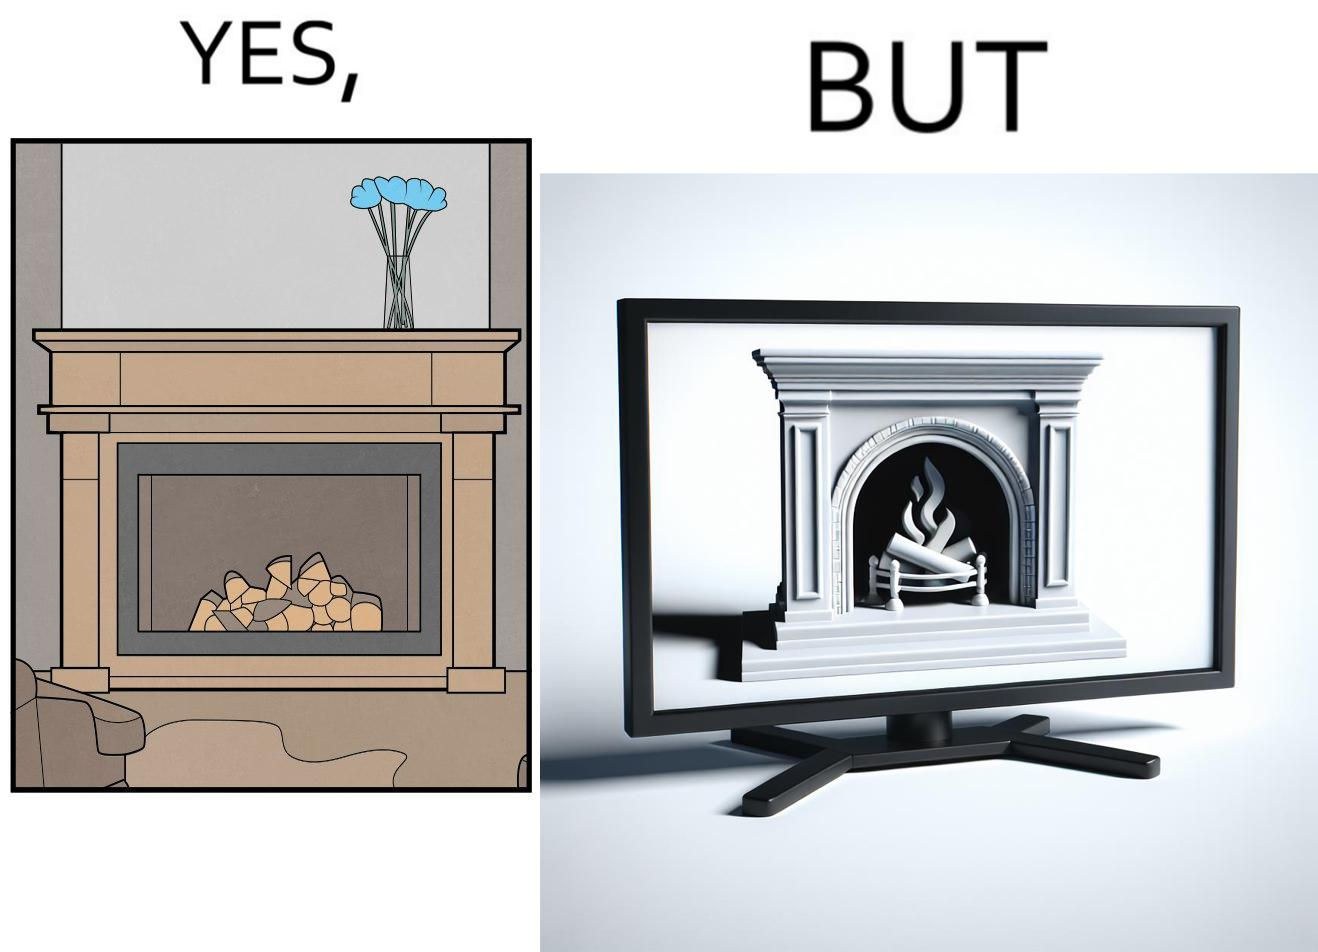Describe what you see in this image. The images are funny since they show how even though real fireplaces exist, people choose to be lazy and watch fireplaces on television because they dont want the inconveniences of cleaning up, etc. afterwards 